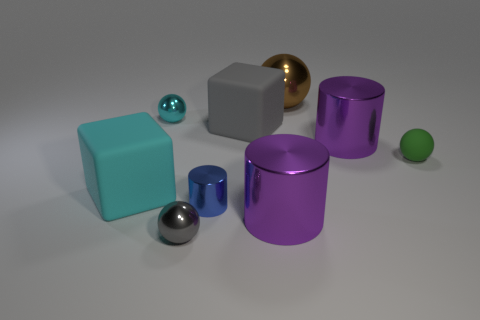Add 1 brown metal things. How many objects exist? 10 Subtract all balls. How many objects are left? 5 Add 7 small gray metallic balls. How many small gray metallic balls exist? 8 Subtract 0 yellow cylinders. How many objects are left? 9 Subtract all big brown rubber objects. Subtract all big brown metallic things. How many objects are left? 8 Add 8 tiny shiny cylinders. How many tiny shiny cylinders are left? 9 